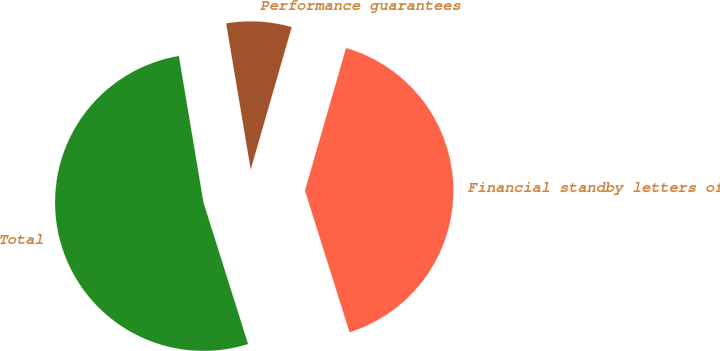Convert chart. <chart><loc_0><loc_0><loc_500><loc_500><pie_chart><fcel>Financial standby letters of<fcel>Performance guarantees<fcel>Total<nl><fcel>40.68%<fcel>7.11%<fcel>52.2%<nl></chart> 